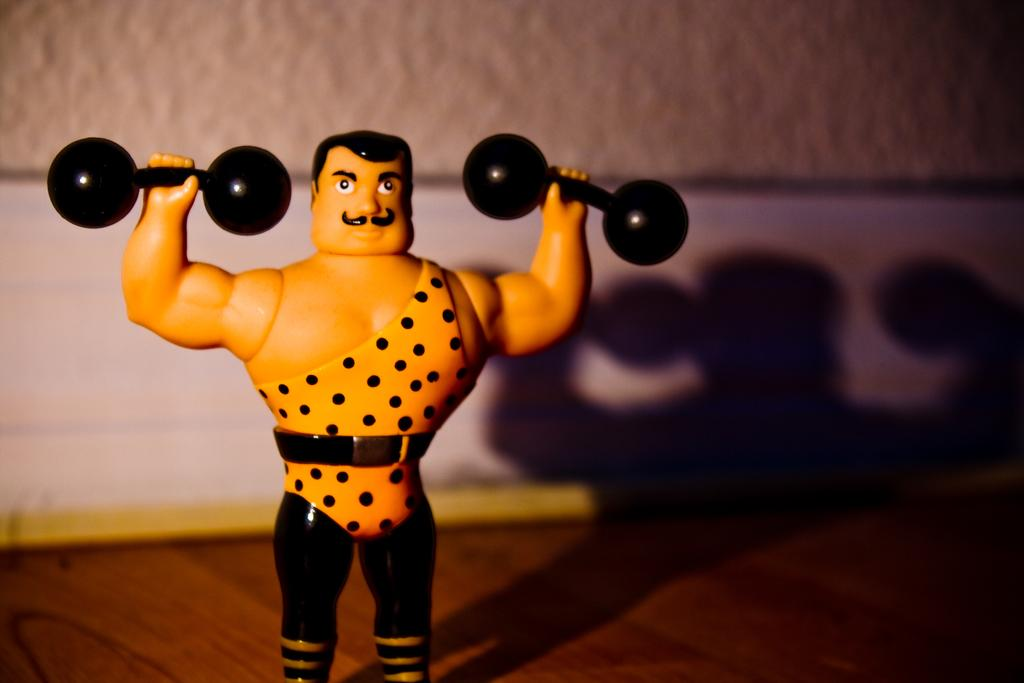What can be seen in the image besides the wall in the background? There is a toy in the image, which is on an object. Can you describe the toy's appearance in the image? The toy has a shadow in the image. What is the primary color of the wall in the background? The provided facts do not mention the color of the wall. How many quince are hanging from the wall in the image? There are no quince present in the image; it features a toy with a shadow and a wall in the background. 